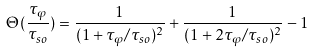<formula> <loc_0><loc_0><loc_500><loc_500>\Theta ( \frac { \tau _ { \varphi } } { \tau _ { s o } } ) = \frac { 1 } { ( 1 + \tau _ { \varphi } / \tau _ { s o } ) ^ { 2 } } + \frac { 1 } { ( 1 + 2 \tau _ { \varphi } / \tau _ { s o } ) ^ { 2 } } - 1</formula> 